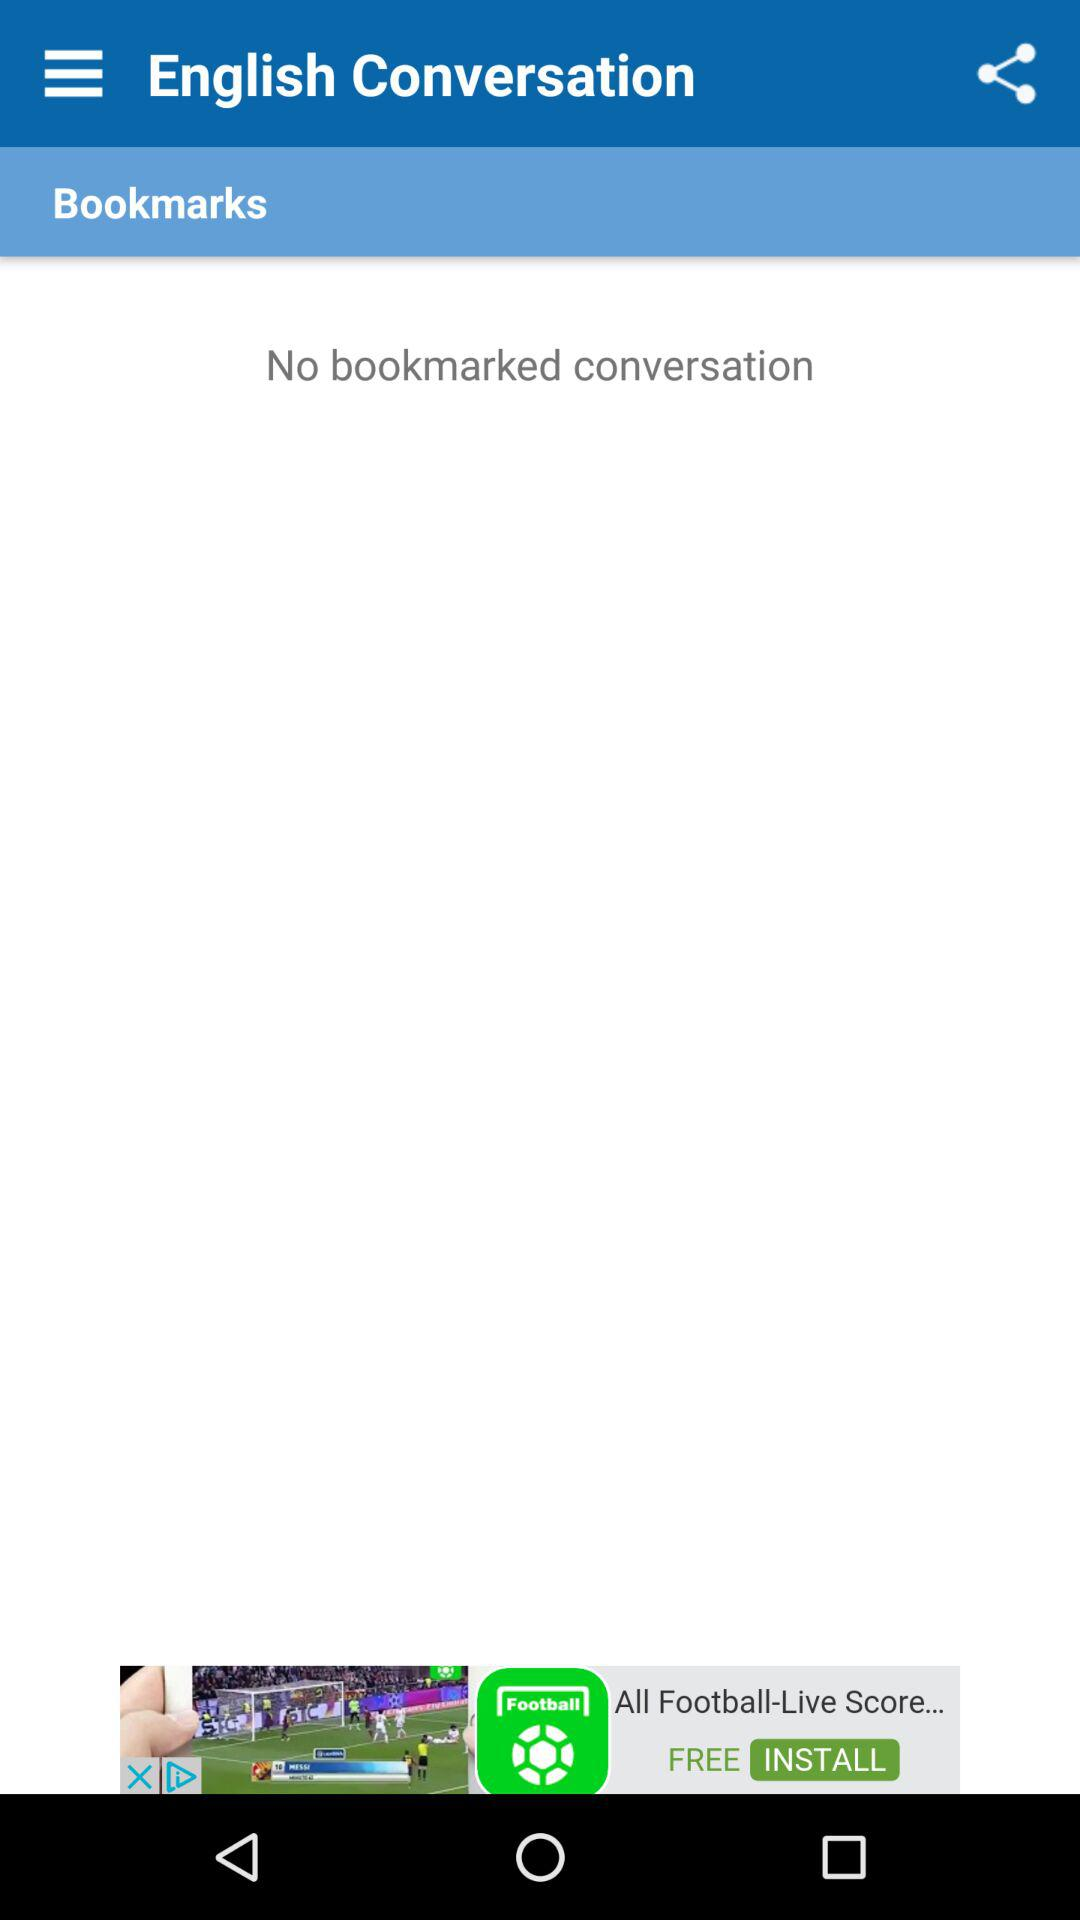Is there any bookmarked conversation? There is no bookmarked conversation. 